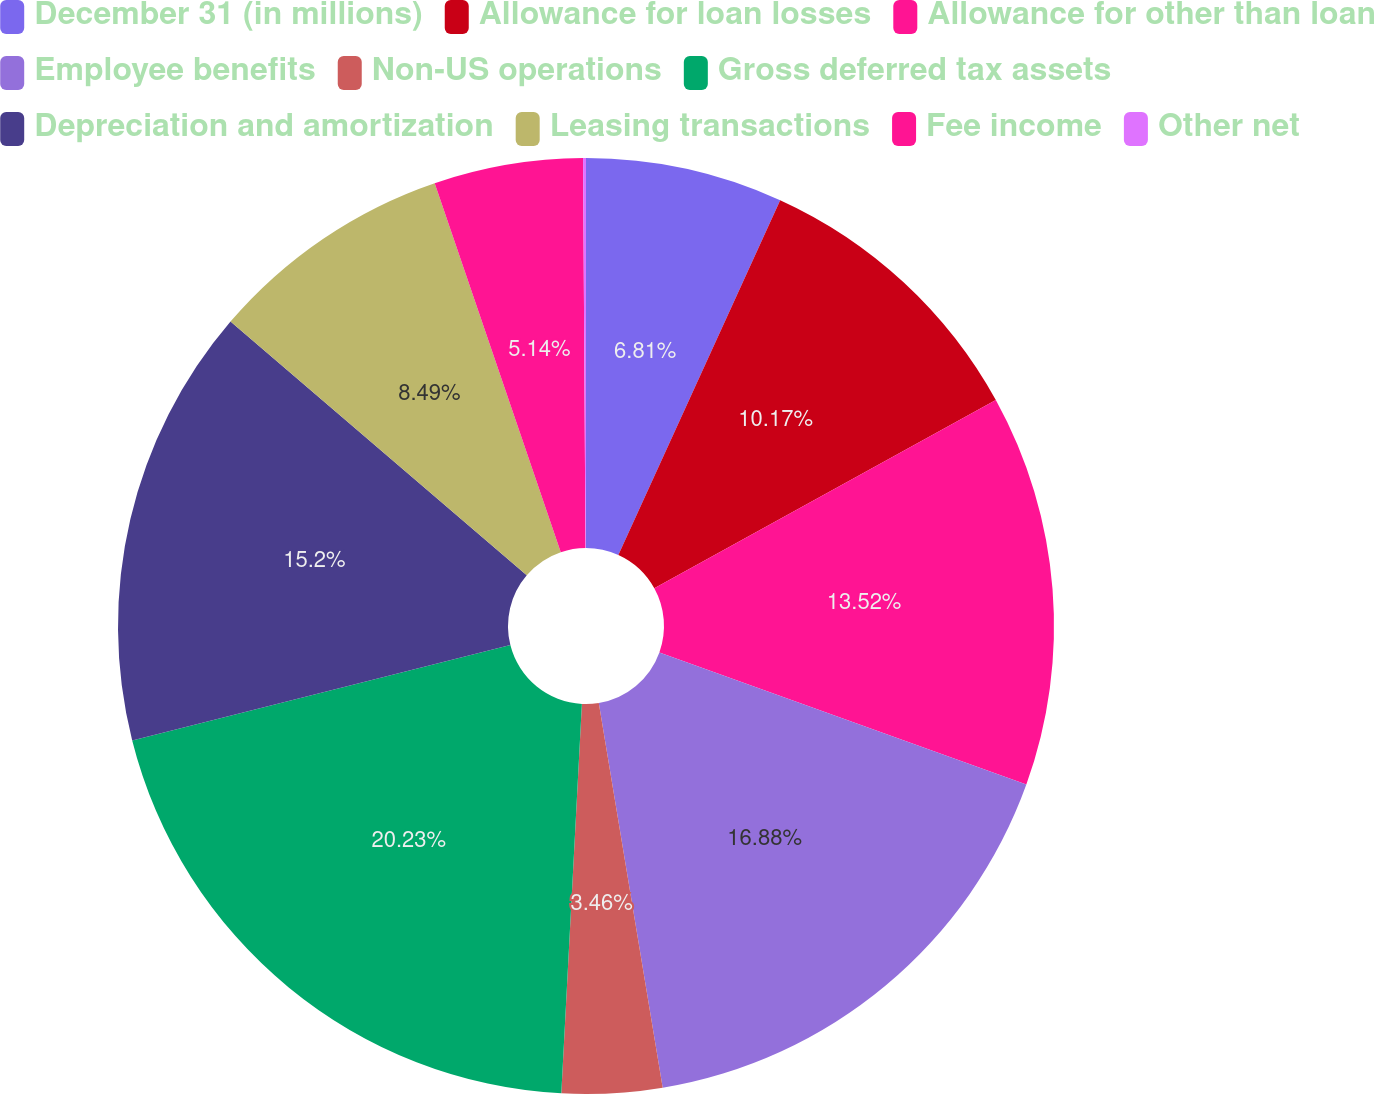Convert chart. <chart><loc_0><loc_0><loc_500><loc_500><pie_chart><fcel>December 31 (in millions)<fcel>Allowance for loan losses<fcel>Allowance for other than loan<fcel>Employee benefits<fcel>Non-US operations<fcel>Gross deferred tax assets<fcel>Depreciation and amortization<fcel>Leasing transactions<fcel>Fee income<fcel>Other net<nl><fcel>6.81%<fcel>10.17%<fcel>13.52%<fcel>16.88%<fcel>3.46%<fcel>20.23%<fcel>15.2%<fcel>8.49%<fcel>5.14%<fcel>0.1%<nl></chart> 